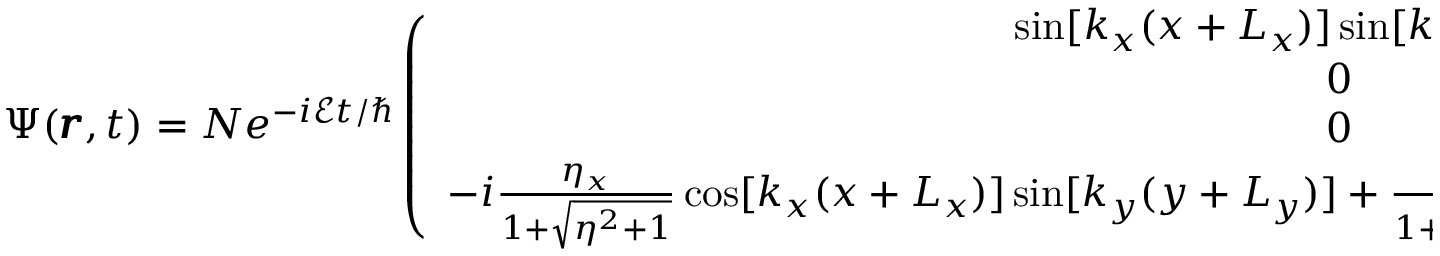<formula> <loc_0><loc_0><loc_500><loc_500>\Psi ( \pm b { r } , t ) = N e ^ { - i \mathcal { E } t / } \left ( \begin{array} { c } { \sin [ k _ { x } ( x + L _ { x } ) ] \sin [ k _ { y } ( y + L _ { y } ) ] } \\ { 0 } \\ { 0 } \\ { - i \frac { \eta _ { x } } { 1 + \sqrt { \eta ^ { 2 } + 1 } } \cos [ k _ { x } ( x + L _ { x } ) ] \sin [ k _ { y } ( y + L _ { y } ) ] + \frac { \eta _ { y } } { 1 + \sqrt { \eta ^ { 2 } + 1 } } \sin [ k _ { x } ( x + L _ { x } ) ] \cos [ k _ { y } ( y + L _ { y } ) ] } \end{array} \right ) .</formula> 